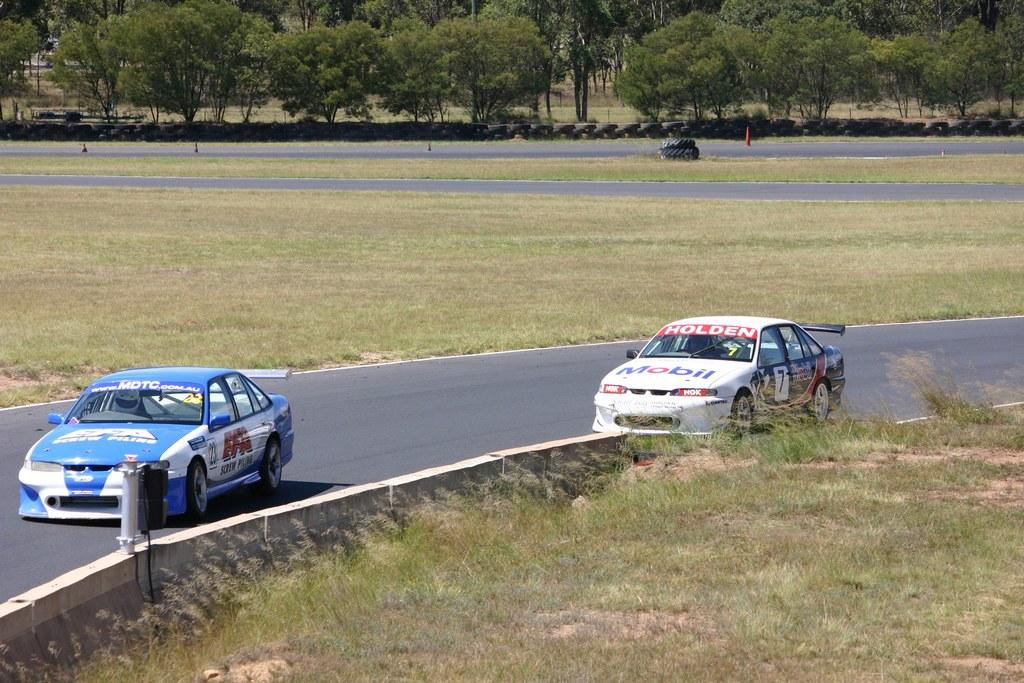What can be seen on the road in the image? There are cars on the road in the image. What type of vegetation is at the bottom of the image? There is grass at the bottom of the image. What can be seen in the distance in the image? There are trees in the background of the image. What parts of the cars are visible in the image? There are tires visible in the image. What safety equipment is present in the image? There are traffic cones in the image. Can you tell me how many times the comb is used in the image? There is no comb present in the image. What type of notebook is visible in the image? There is no notebook present in the image. 